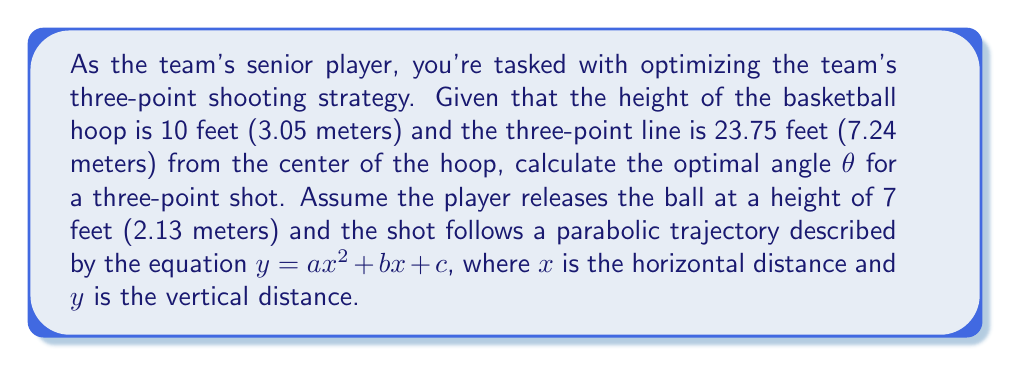Give your solution to this math problem. Let's approach this step-by-step:

1) First, we need to set up our coordinate system. Let's set the origin (0,0) at the point where the player releases the ball.

2) We know two points on our parabola:
   - The release point: (0, 0)
   - The basket: (23.75, 3)

3) We can use these points to set up two equations:
   $0 = c$ (release point)
   $3 = a(23.75)^2 + b(23.75)$ (basket)

4) The general equation for the angle of elevation at any point on a parabola is:
   $\tan θ = \frac{dy}{dx} = 2ax + b$

5) At the release point (0,0), this becomes:
   $\tan θ = b$

6) We can use the quadratic formula to find the maximum height of the parabola:
   $x_{max} = -\frac{b}{2a}$
   $y_{max} = -\frac{b^2}{4a} + c = -\frac{b^2}{4a}$ (since $c = 0$)

7) For the optimal trajectory, we want the maximum height to be just enough to clear the hoop. The hoop is 3 feet higher than the release point, so:
   $y_{max} = 3$

8) Substituting this into our equation from step 6:
   $3 = -\frac{b^2}{4a}$

9) From our equation in step 3:
   $3 = a(23.75)^2 + 23.75b$

10) Solving these equations simultaneously:
    $a = -0.0053$
    $b = 0.6325$

11) Therefore, the optimal angle θ is:
    $θ = \arctan(0.6325) = 32.3°$

[asy]
import geometry;

size(200);
real xScale = 8;
real yScale = 30;

void drawAxes() {
  draw((0,0)--(xScale,0), arrow=Arrow);
  draw((0,0)--(0,yScale/xScale), arrow=Arrow);
  label("x", (xScale,0), E);
  label("y", (0,yScale/xScale), N);
}

drawAxes();

path p = graph(new real(real x) { return -0.0053*x^2 + 0.6325*x; }, 0, 23.75);
draw(p, red);

dot((0,0));
dot((23.75, 3*xScale/yScale));

draw((0,0)--(5,0.6325*5), blue, arrow=Arrow);
label("θ", (2,0.6325), NW);

label("Release point", (0,0), SW);
label("Basket", (23.75, 3*xScale/yScale), SE);

[/asy]
Answer: $32.3°$ 